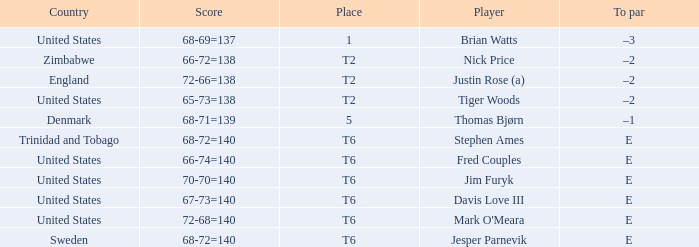The player for which country had a score of 66-72=138? Zimbabwe. 